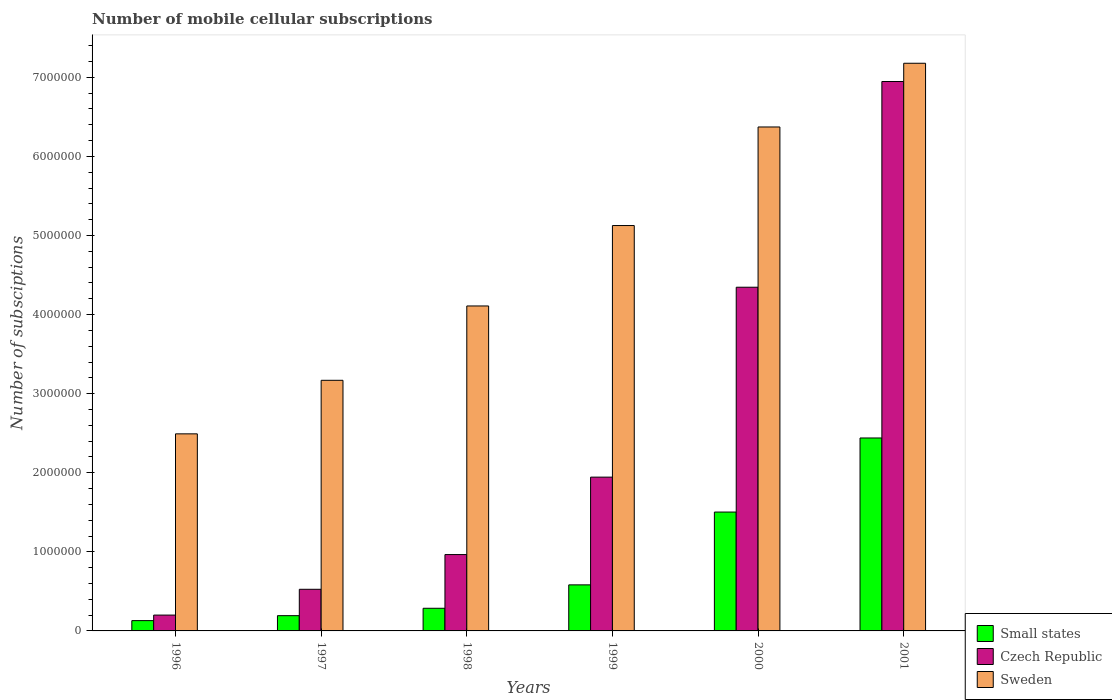How many different coloured bars are there?
Ensure brevity in your answer.  3. How many groups of bars are there?
Provide a succinct answer. 6. How many bars are there on the 4th tick from the left?
Make the answer very short. 3. How many bars are there on the 6th tick from the right?
Offer a terse response. 3. What is the number of mobile cellular subscriptions in Small states in 1998?
Offer a very short reply. 2.86e+05. Across all years, what is the maximum number of mobile cellular subscriptions in Czech Republic?
Offer a very short reply. 6.95e+06. Across all years, what is the minimum number of mobile cellular subscriptions in Czech Republic?
Make the answer very short. 2.00e+05. In which year was the number of mobile cellular subscriptions in Small states maximum?
Your response must be concise. 2001. In which year was the number of mobile cellular subscriptions in Sweden minimum?
Your answer should be compact. 1996. What is the total number of mobile cellular subscriptions in Sweden in the graph?
Offer a very short reply. 2.84e+07. What is the difference between the number of mobile cellular subscriptions in Sweden in 1996 and that in 1998?
Give a very brief answer. -1.62e+06. What is the difference between the number of mobile cellular subscriptions in Czech Republic in 1996 and the number of mobile cellular subscriptions in Small states in 1999?
Provide a succinct answer. -3.82e+05. What is the average number of mobile cellular subscriptions in Czech Republic per year?
Offer a terse response. 2.49e+06. In the year 1996, what is the difference between the number of mobile cellular subscriptions in Czech Republic and number of mobile cellular subscriptions in Sweden?
Offer a very short reply. -2.29e+06. What is the ratio of the number of mobile cellular subscriptions in Small states in 1998 to that in 2000?
Keep it short and to the point. 0.19. What is the difference between the highest and the second highest number of mobile cellular subscriptions in Small states?
Offer a very short reply. 9.37e+05. What is the difference between the highest and the lowest number of mobile cellular subscriptions in Czech Republic?
Your answer should be compact. 6.75e+06. In how many years, is the number of mobile cellular subscriptions in Sweden greater than the average number of mobile cellular subscriptions in Sweden taken over all years?
Give a very brief answer. 3. Is the sum of the number of mobile cellular subscriptions in Sweden in 1997 and 1999 greater than the maximum number of mobile cellular subscriptions in Czech Republic across all years?
Provide a short and direct response. Yes. What does the 3rd bar from the left in 1997 represents?
Provide a succinct answer. Sweden. What does the 2nd bar from the right in 1998 represents?
Ensure brevity in your answer.  Czech Republic. Is it the case that in every year, the sum of the number of mobile cellular subscriptions in Sweden and number of mobile cellular subscriptions in Czech Republic is greater than the number of mobile cellular subscriptions in Small states?
Offer a terse response. Yes. How many bars are there?
Give a very brief answer. 18. Are all the bars in the graph horizontal?
Ensure brevity in your answer.  No. What is the difference between two consecutive major ticks on the Y-axis?
Keep it short and to the point. 1.00e+06. Are the values on the major ticks of Y-axis written in scientific E-notation?
Provide a succinct answer. No. Does the graph contain any zero values?
Provide a short and direct response. No. How are the legend labels stacked?
Keep it short and to the point. Vertical. What is the title of the graph?
Make the answer very short. Number of mobile cellular subscriptions. Does "Seychelles" appear as one of the legend labels in the graph?
Ensure brevity in your answer.  No. What is the label or title of the Y-axis?
Make the answer very short. Number of subsciptions. What is the Number of subsciptions of Small states in 1996?
Ensure brevity in your answer.  1.30e+05. What is the Number of subsciptions of Czech Republic in 1996?
Ensure brevity in your answer.  2.00e+05. What is the Number of subsciptions of Sweden in 1996?
Ensure brevity in your answer.  2.49e+06. What is the Number of subsciptions of Small states in 1997?
Your answer should be very brief. 1.93e+05. What is the Number of subsciptions in Czech Republic in 1997?
Ensure brevity in your answer.  5.26e+05. What is the Number of subsciptions of Sweden in 1997?
Provide a short and direct response. 3.17e+06. What is the Number of subsciptions of Small states in 1998?
Your answer should be compact. 2.86e+05. What is the Number of subsciptions of Czech Republic in 1998?
Your response must be concise. 9.65e+05. What is the Number of subsciptions of Sweden in 1998?
Give a very brief answer. 4.11e+06. What is the Number of subsciptions in Small states in 1999?
Provide a short and direct response. 5.82e+05. What is the Number of subsciptions in Czech Republic in 1999?
Give a very brief answer. 1.94e+06. What is the Number of subsciptions of Sweden in 1999?
Give a very brief answer. 5.13e+06. What is the Number of subsciptions of Small states in 2000?
Ensure brevity in your answer.  1.50e+06. What is the Number of subsciptions of Czech Republic in 2000?
Your answer should be very brief. 4.35e+06. What is the Number of subsciptions in Sweden in 2000?
Your answer should be very brief. 6.37e+06. What is the Number of subsciptions in Small states in 2001?
Offer a terse response. 2.44e+06. What is the Number of subsciptions in Czech Republic in 2001?
Your response must be concise. 6.95e+06. What is the Number of subsciptions in Sweden in 2001?
Your answer should be compact. 7.18e+06. Across all years, what is the maximum Number of subsciptions in Small states?
Your answer should be compact. 2.44e+06. Across all years, what is the maximum Number of subsciptions in Czech Republic?
Make the answer very short. 6.95e+06. Across all years, what is the maximum Number of subsciptions of Sweden?
Offer a very short reply. 7.18e+06. Across all years, what is the minimum Number of subsciptions of Small states?
Keep it short and to the point. 1.30e+05. Across all years, what is the minimum Number of subsciptions in Czech Republic?
Offer a terse response. 2.00e+05. Across all years, what is the minimum Number of subsciptions in Sweden?
Offer a terse response. 2.49e+06. What is the total Number of subsciptions of Small states in the graph?
Your answer should be compact. 5.13e+06. What is the total Number of subsciptions in Czech Republic in the graph?
Provide a short and direct response. 1.49e+07. What is the total Number of subsciptions in Sweden in the graph?
Ensure brevity in your answer.  2.84e+07. What is the difference between the Number of subsciptions in Small states in 1996 and that in 1997?
Make the answer very short. -6.26e+04. What is the difference between the Number of subsciptions in Czech Republic in 1996 and that in 1997?
Ensure brevity in your answer.  -3.26e+05. What is the difference between the Number of subsciptions of Sweden in 1996 and that in 1997?
Provide a succinct answer. -6.77e+05. What is the difference between the Number of subsciptions in Small states in 1996 and that in 1998?
Provide a short and direct response. -1.56e+05. What is the difference between the Number of subsciptions in Czech Republic in 1996 and that in 1998?
Ensure brevity in your answer.  -7.65e+05. What is the difference between the Number of subsciptions in Sweden in 1996 and that in 1998?
Offer a very short reply. -1.62e+06. What is the difference between the Number of subsciptions in Small states in 1996 and that in 1999?
Provide a short and direct response. -4.52e+05. What is the difference between the Number of subsciptions of Czech Republic in 1996 and that in 1999?
Make the answer very short. -1.74e+06. What is the difference between the Number of subsciptions of Sweden in 1996 and that in 1999?
Offer a very short reply. -2.63e+06. What is the difference between the Number of subsciptions of Small states in 1996 and that in 2000?
Make the answer very short. -1.37e+06. What is the difference between the Number of subsciptions of Czech Republic in 1996 and that in 2000?
Your answer should be compact. -4.15e+06. What is the difference between the Number of subsciptions in Sweden in 1996 and that in 2000?
Offer a terse response. -3.88e+06. What is the difference between the Number of subsciptions in Small states in 1996 and that in 2001?
Ensure brevity in your answer.  -2.31e+06. What is the difference between the Number of subsciptions in Czech Republic in 1996 and that in 2001?
Offer a very short reply. -6.75e+06. What is the difference between the Number of subsciptions in Sweden in 1996 and that in 2001?
Offer a terse response. -4.69e+06. What is the difference between the Number of subsciptions of Small states in 1997 and that in 1998?
Make the answer very short. -9.34e+04. What is the difference between the Number of subsciptions in Czech Republic in 1997 and that in 1998?
Your answer should be compact. -4.39e+05. What is the difference between the Number of subsciptions of Sweden in 1997 and that in 1998?
Provide a succinct answer. -9.40e+05. What is the difference between the Number of subsciptions of Small states in 1997 and that in 1999?
Ensure brevity in your answer.  -3.90e+05. What is the difference between the Number of subsciptions in Czech Republic in 1997 and that in 1999?
Provide a short and direct response. -1.42e+06. What is the difference between the Number of subsciptions in Sweden in 1997 and that in 1999?
Your answer should be compact. -1.96e+06. What is the difference between the Number of subsciptions of Small states in 1997 and that in 2000?
Make the answer very short. -1.31e+06. What is the difference between the Number of subsciptions in Czech Republic in 1997 and that in 2000?
Your answer should be compact. -3.82e+06. What is the difference between the Number of subsciptions in Sweden in 1997 and that in 2000?
Offer a very short reply. -3.20e+06. What is the difference between the Number of subsciptions in Small states in 1997 and that in 2001?
Provide a short and direct response. -2.25e+06. What is the difference between the Number of subsciptions in Czech Republic in 1997 and that in 2001?
Give a very brief answer. -6.42e+06. What is the difference between the Number of subsciptions of Sweden in 1997 and that in 2001?
Ensure brevity in your answer.  -4.01e+06. What is the difference between the Number of subsciptions in Small states in 1998 and that in 1999?
Keep it short and to the point. -2.96e+05. What is the difference between the Number of subsciptions of Czech Republic in 1998 and that in 1999?
Give a very brief answer. -9.79e+05. What is the difference between the Number of subsciptions of Sweden in 1998 and that in 1999?
Make the answer very short. -1.02e+06. What is the difference between the Number of subsciptions in Small states in 1998 and that in 2000?
Offer a very short reply. -1.22e+06. What is the difference between the Number of subsciptions in Czech Republic in 1998 and that in 2000?
Offer a terse response. -3.38e+06. What is the difference between the Number of subsciptions in Sweden in 1998 and that in 2000?
Provide a short and direct response. -2.26e+06. What is the difference between the Number of subsciptions in Small states in 1998 and that in 2001?
Keep it short and to the point. -2.15e+06. What is the difference between the Number of subsciptions of Czech Republic in 1998 and that in 2001?
Keep it short and to the point. -5.98e+06. What is the difference between the Number of subsciptions of Sweden in 1998 and that in 2001?
Make the answer very short. -3.07e+06. What is the difference between the Number of subsciptions of Small states in 1999 and that in 2000?
Ensure brevity in your answer.  -9.21e+05. What is the difference between the Number of subsciptions in Czech Republic in 1999 and that in 2000?
Your answer should be compact. -2.40e+06. What is the difference between the Number of subsciptions of Sweden in 1999 and that in 2000?
Your answer should be compact. -1.25e+06. What is the difference between the Number of subsciptions of Small states in 1999 and that in 2001?
Give a very brief answer. -1.86e+06. What is the difference between the Number of subsciptions in Czech Republic in 1999 and that in 2001?
Offer a terse response. -5.00e+06. What is the difference between the Number of subsciptions in Sweden in 1999 and that in 2001?
Your answer should be compact. -2.05e+06. What is the difference between the Number of subsciptions in Small states in 2000 and that in 2001?
Provide a short and direct response. -9.37e+05. What is the difference between the Number of subsciptions in Czech Republic in 2000 and that in 2001?
Your answer should be compact. -2.60e+06. What is the difference between the Number of subsciptions in Sweden in 2000 and that in 2001?
Give a very brief answer. -8.06e+05. What is the difference between the Number of subsciptions of Small states in 1996 and the Number of subsciptions of Czech Republic in 1997?
Ensure brevity in your answer.  -3.96e+05. What is the difference between the Number of subsciptions of Small states in 1996 and the Number of subsciptions of Sweden in 1997?
Your response must be concise. -3.04e+06. What is the difference between the Number of subsciptions of Czech Republic in 1996 and the Number of subsciptions of Sweden in 1997?
Give a very brief answer. -2.97e+06. What is the difference between the Number of subsciptions of Small states in 1996 and the Number of subsciptions of Czech Republic in 1998?
Offer a very short reply. -8.35e+05. What is the difference between the Number of subsciptions in Small states in 1996 and the Number of subsciptions in Sweden in 1998?
Give a very brief answer. -3.98e+06. What is the difference between the Number of subsciptions in Czech Republic in 1996 and the Number of subsciptions in Sweden in 1998?
Your response must be concise. -3.91e+06. What is the difference between the Number of subsciptions of Small states in 1996 and the Number of subsciptions of Czech Republic in 1999?
Give a very brief answer. -1.81e+06. What is the difference between the Number of subsciptions in Small states in 1996 and the Number of subsciptions in Sweden in 1999?
Your answer should be compact. -5.00e+06. What is the difference between the Number of subsciptions in Czech Republic in 1996 and the Number of subsciptions in Sweden in 1999?
Keep it short and to the point. -4.93e+06. What is the difference between the Number of subsciptions in Small states in 1996 and the Number of subsciptions in Czech Republic in 2000?
Ensure brevity in your answer.  -4.22e+06. What is the difference between the Number of subsciptions in Small states in 1996 and the Number of subsciptions in Sweden in 2000?
Make the answer very short. -6.24e+06. What is the difference between the Number of subsciptions in Czech Republic in 1996 and the Number of subsciptions in Sweden in 2000?
Give a very brief answer. -6.17e+06. What is the difference between the Number of subsciptions of Small states in 1996 and the Number of subsciptions of Czech Republic in 2001?
Your response must be concise. -6.82e+06. What is the difference between the Number of subsciptions of Small states in 1996 and the Number of subsciptions of Sweden in 2001?
Give a very brief answer. -7.05e+06. What is the difference between the Number of subsciptions in Czech Republic in 1996 and the Number of subsciptions in Sweden in 2001?
Keep it short and to the point. -6.98e+06. What is the difference between the Number of subsciptions in Small states in 1997 and the Number of subsciptions in Czech Republic in 1998?
Offer a terse response. -7.73e+05. What is the difference between the Number of subsciptions in Small states in 1997 and the Number of subsciptions in Sweden in 1998?
Offer a terse response. -3.92e+06. What is the difference between the Number of subsciptions of Czech Republic in 1997 and the Number of subsciptions of Sweden in 1998?
Your answer should be very brief. -3.58e+06. What is the difference between the Number of subsciptions in Small states in 1997 and the Number of subsciptions in Czech Republic in 1999?
Keep it short and to the point. -1.75e+06. What is the difference between the Number of subsciptions of Small states in 1997 and the Number of subsciptions of Sweden in 1999?
Make the answer very short. -4.93e+06. What is the difference between the Number of subsciptions of Czech Republic in 1997 and the Number of subsciptions of Sweden in 1999?
Your answer should be compact. -4.60e+06. What is the difference between the Number of subsciptions of Small states in 1997 and the Number of subsciptions of Czech Republic in 2000?
Provide a succinct answer. -4.15e+06. What is the difference between the Number of subsciptions in Small states in 1997 and the Number of subsciptions in Sweden in 2000?
Your answer should be very brief. -6.18e+06. What is the difference between the Number of subsciptions in Czech Republic in 1997 and the Number of subsciptions in Sweden in 2000?
Your answer should be very brief. -5.85e+06. What is the difference between the Number of subsciptions of Small states in 1997 and the Number of subsciptions of Czech Republic in 2001?
Make the answer very short. -6.75e+06. What is the difference between the Number of subsciptions of Small states in 1997 and the Number of subsciptions of Sweden in 2001?
Offer a very short reply. -6.99e+06. What is the difference between the Number of subsciptions in Czech Republic in 1997 and the Number of subsciptions in Sweden in 2001?
Your answer should be very brief. -6.65e+06. What is the difference between the Number of subsciptions of Small states in 1998 and the Number of subsciptions of Czech Republic in 1999?
Give a very brief answer. -1.66e+06. What is the difference between the Number of subsciptions of Small states in 1998 and the Number of subsciptions of Sweden in 1999?
Provide a short and direct response. -4.84e+06. What is the difference between the Number of subsciptions in Czech Republic in 1998 and the Number of subsciptions in Sweden in 1999?
Your answer should be compact. -4.16e+06. What is the difference between the Number of subsciptions in Small states in 1998 and the Number of subsciptions in Czech Republic in 2000?
Give a very brief answer. -4.06e+06. What is the difference between the Number of subsciptions of Small states in 1998 and the Number of subsciptions of Sweden in 2000?
Provide a succinct answer. -6.09e+06. What is the difference between the Number of subsciptions of Czech Republic in 1998 and the Number of subsciptions of Sweden in 2000?
Give a very brief answer. -5.41e+06. What is the difference between the Number of subsciptions in Small states in 1998 and the Number of subsciptions in Czech Republic in 2001?
Your answer should be compact. -6.66e+06. What is the difference between the Number of subsciptions of Small states in 1998 and the Number of subsciptions of Sweden in 2001?
Offer a very short reply. -6.89e+06. What is the difference between the Number of subsciptions in Czech Republic in 1998 and the Number of subsciptions in Sweden in 2001?
Provide a short and direct response. -6.21e+06. What is the difference between the Number of subsciptions of Small states in 1999 and the Number of subsciptions of Czech Republic in 2000?
Give a very brief answer. -3.76e+06. What is the difference between the Number of subsciptions in Small states in 1999 and the Number of subsciptions in Sweden in 2000?
Your answer should be very brief. -5.79e+06. What is the difference between the Number of subsciptions in Czech Republic in 1999 and the Number of subsciptions in Sweden in 2000?
Keep it short and to the point. -4.43e+06. What is the difference between the Number of subsciptions of Small states in 1999 and the Number of subsciptions of Czech Republic in 2001?
Your response must be concise. -6.36e+06. What is the difference between the Number of subsciptions of Small states in 1999 and the Number of subsciptions of Sweden in 2001?
Offer a terse response. -6.60e+06. What is the difference between the Number of subsciptions in Czech Republic in 1999 and the Number of subsciptions in Sweden in 2001?
Give a very brief answer. -5.23e+06. What is the difference between the Number of subsciptions in Small states in 2000 and the Number of subsciptions in Czech Republic in 2001?
Offer a terse response. -5.44e+06. What is the difference between the Number of subsciptions in Small states in 2000 and the Number of subsciptions in Sweden in 2001?
Provide a succinct answer. -5.67e+06. What is the difference between the Number of subsciptions in Czech Republic in 2000 and the Number of subsciptions in Sweden in 2001?
Offer a very short reply. -2.83e+06. What is the average Number of subsciptions in Small states per year?
Ensure brevity in your answer.  8.56e+05. What is the average Number of subsciptions of Czech Republic per year?
Give a very brief answer. 2.49e+06. What is the average Number of subsciptions of Sweden per year?
Your answer should be compact. 4.74e+06. In the year 1996, what is the difference between the Number of subsciptions in Small states and Number of subsciptions in Czech Republic?
Ensure brevity in your answer.  -7.01e+04. In the year 1996, what is the difference between the Number of subsciptions in Small states and Number of subsciptions in Sweden?
Your answer should be compact. -2.36e+06. In the year 1996, what is the difference between the Number of subsciptions of Czech Republic and Number of subsciptions of Sweden?
Your answer should be very brief. -2.29e+06. In the year 1997, what is the difference between the Number of subsciptions of Small states and Number of subsciptions of Czech Republic?
Provide a succinct answer. -3.33e+05. In the year 1997, what is the difference between the Number of subsciptions of Small states and Number of subsciptions of Sweden?
Offer a terse response. -2.98e+06. In the year 1997, what is the difference between the Number of subsciptions of Czech Republic and Number of subsciptions of Sweden?
Offer a terse response. -2.64e+06. In the year 1998, what is the difference between the Number of subsciptions in Small states and Number of subsciptions in Czech Republic?
Ensure brevity in your answer.  -6.79e+05. In the year 1998, what is the difference between the Number of subsciptions in Small states and Number of subsciptions in Sweden?
Ensure brevity in your answer.  -3.82e+06. In the year 1998, what is the difference between the Number of subsciptions of Czech Republic and Number of subsciptions of Sweden?
Provide a succinct answer. -3.14e+06. In the year 1999, what is the difference between the Number of subsciptions in Small states and Number of subsciptions in Czech Republic?
Provide a short and direct response. -1.36e+06. In the year 1999, what is the difference between the Number of subsciptions in Small states and Number of subsciptions in Sweden?
Your answer should be very brief. -4.54e+06. In the year 1999, what is the difference between the Number of subsciptions in Czech Republic and Number of subsciptions in Sweden?
Your response must be concise. -3.18e+06. In the year 2000, what is the difference between the Number of subsciptions in Small states and Number of subsciptions in Czech Republic?
Make the answer very short. -2.84e+06. In the year 2000, what is the difference between the Number of subsciptions of Small states and Number of subsciptions of Sweden?
Your answer should be compact. -4.87e+06. In the year 2000, what is the difference between the Number of subsciptions of Czech Republic and Number of subsciptions of Sweden?
Provide a succinct answer. -2.03e+06. In the year 2001, what is the difference between the Number of subsciptions in Small states and Number of subsciptions in Czech Republic?
Make the answer very short. -4.51e+06. In the year 2001, what is the difference between the Number of subsciptions in Small states and Number of subsciptions in Sweden?
Give a very brief answer. -4.74e+06. In the year 2001, what is the difference between the Number of subsciptions of Czech Republic and Number of subsciptions of Sweden?
Your answer should be compact. -2.31e+05. What is the ratio of the Number of subsciptions in Small states in 1996 to that in 1997?
Provide a succinct answer. 0.68. What is the ratio of the Number of subsciptions in Czech Republic in 1996 to that in 1997?
Your answer should be compact. 0.38. What is the ratio of the Number of subsciptions in Sweden in 1996 to that in 1997?
Your answer should be compact. 0.79. What is the ratio of the Number of subsciptions in Small states in 1996 to that in 1998?
Provide a succinct answer. 0.46. What is the ratio of the Number of subsciptions in Czech Republic in 1996 to that in 1998?
Your answer should be compact. 0.21. What is the ratio of the Number of subsciptions of Sweden in 1996 to that in 1998?
Your response must be concise. 0.61. What is the ratio of the Number of subsciptions in Small states in 1996 to that in 1999?
Your answer should be compact. 0.22. What is the ratio of the Number of subsciptions of Czech Republic in 1996 to that in 1999?
Keep it short and to the point. 0.1. What is the ratio of the Number of subsciptions in Sweden in 1996 to that in 1999?
Offer a very short reply. 0.49. What is the ratio of the Number of subsciptions of Small states in 1996 to that in 2000?
Your answer should be very brief. 0.09. What is the ratio of the Number of subsciptions in Czech Republic in 1996 to that in 2000?
Offer a very short reply. 0.05. What is the ratio of the Number of subsciptions of Sweden in 1996 to that in 2000?
Your answer should be compact. 0.39. What is the ratio of the Number of subsciptions of Small states in 1996 to that in 2001?
Keep it short and to the point. 0.05. What is the ratio of the Number of subsciptions in Czech Republic in 1996 to that in 2001?
Your answer should be very brief. 0.03. What is the ratio of the Number of subsciptions in Sweden in 1996 to that in 2001?
Make the answer very short. 0.35. What is the ratio of the Number of subsciptions of Small states in 1997 to that in 1998?
Ensure brevity in your answer.  0.67. What is the ratio of the Number of subsciptions in Czech Republic in 1997 to that in 1998?
Provide a short and direct response. 0.55. What is the ratio of the Number of subsciptions in Sweden in 1997 to that in 1998?
Give a very brief answer. 0.77. What is the ratio of the Number of subsciptions of Small states in 1997 to that in 1999?
Provide a succinct answer. 0.33. What is the ratio of the Number of subsciptions of Czech Republic in 1997 to that in 1999?
Provide a short and direct response. 0.27. What is the ratio of the Number of subsciptions in Sweden in 1997 to that in 1999?
Give a very brief answer. 0.62. What is the ratio of the Number of subsciptions in Small states in 1997 to that in 2000?
Provide a succinct answer. 0.13. What is the ratio of the Number of subsciptions in Czech Republic in 1997 to that in 2000?
Provide a succinct answer. 0.12. What is the ratio of the Number of subsciptions in Sweden in 1997 to that in 2000?
Your response must be concise. 0.5. What is the ratio of the Number of subsciptions of Small states in 1997 to that in 2001?
Offer a very short reply. 0.08. What is the ratio of the Number of subsciptions in Czech Republic in 1997 to that in 2001?
Give a very brief answer. 0.08. What is the ratio of the Number of subsciptions in Sweden in 1997 to that in 2001?
Keep it short and to the point. 0.44. What is the ratio of the Number of subsciptions in Small states in 1998 to that in 1999?
Provide a short and direct response. 0.49. What is the ratio of the Number of subsciptions in Czech Republic in 1998 to that in 1999?
Make the answer very short. 0.5. What is the ratio of the Number of subsciptions of Sweden in 1998 to that in 1999?
Your answer should be compact. 0.8. What is the ratio of the Number of subsciptions in Small states in 1998 to that in 2000?
Provide a short and direct response. 0.19. What is the ratio of the Number of subsciptions of Czech Republic in 1998 to that in 2000?
Offer a terse response. 0.22. What is the ratio of the Number of subsciptions in Sweden in 1998 to that in 2000?
Keep it short and to the point. 0.64. What is the ratio of the Number of subsciptions in Small states in 1998 to that in 2001?
Keep it short and to the point. 0.12. What is the ratio of the Number of subsciptions in Czech Republic in 1998 to that in 2001?
Offer a very short reply. 0.14. What is the ratio of the Number of subsciptions of Sweden in 1998 to that in 2001?
Provide a succinct answer. 0.57. What is the ratio of the Number of subsciptions of Small states in 1999 to that in 2000?
Offer a very short reply. 0.39. What is the ratio of the Number of subsciptions of Czech Republic in 1999 to that in 2000?
Ensure brevity in your answer.  0.45. What is the ratio of the Number of subsciptions in Sweden in 1999 to that in 2000?
Offer a very short reply. 0.8. What is the ratio of the Number of subsciptions in Small states in 1999 to that in 2001?
Provide a succinct answer. 0.24. What is the ratio of the Number of subsciptions of Czech Republic in 1999 to that in 2001?
Your response must be concise. 0.28. What is the ratio of the Number of subsciptions of Sweden in 1999 to that in 2001?
Offer a very short reply. 0.71. What is the ratio of the Number of subsciptions in Small states in 2000 to that in 2001?
Make the answer very short. 0.62. What is the ratio of the Number of subsciptions of Czech Republic in 2000 to that in 2001?
Give a very brief answer. 0.63. What is the ratio of the Number of subsciptions in Sweden in 2000 to that in 2001?
Offer a terse response. 0.89. What is the difference between the highest and the second highest Number of subsciptions of Small states?
Provide a succinct answer. 9.37e+05. What is the difference between the highest and the second highest Number of subsciptions in Czech Republic?
Keep it short and to the point. 2.60e+06. What is the difference between the highest and the second highest Number of subsciptions in Sweden?
Ensure brevity in your answer.  8.06e+05. What is the difference between the highest and the lowest Number of subsciptions of Small states?
Give a very brief answer. 2.31e+06. What is the difference between the highest and the lowest Number of subsciptions in Czech Republic?
Ensure brevity in your answer.  6.75e+06. What is the difference between the highest and the lowest Number of subsciptions in Sweden?
Your answer should be very brief. 4.69e+06. 